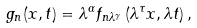Convert formula to latex. <formula><loc_0><loc_0><loc_500><loc_500>g _ { n } ( x , t ) = \lambda ^ { \alpha } f _ { n \lambda ^ { \gamma } } \left ( \lambda ^ { \tau } x , \lambda t \right ) ,</formula> 